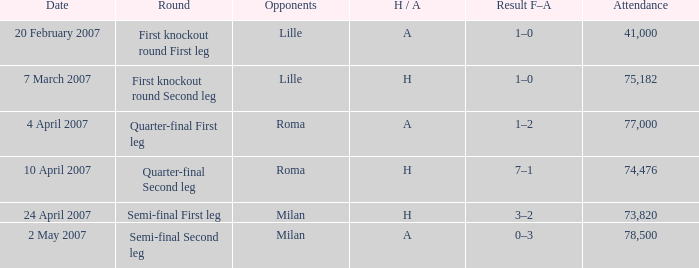Which round happened on 10 april 2007? Quarter-final Second leg. 